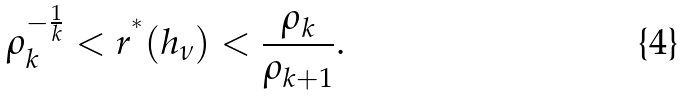<formula> <loc_0><loc_0><loc_500><loc_500>\rho _ { k } ^ { - \frac { 1 } { k } } < r ^ { ^ { * } } ( h _ { \nu } ) < \frac { \rho _ { k } } { \rho _ { k + 1 } } .</formula> 